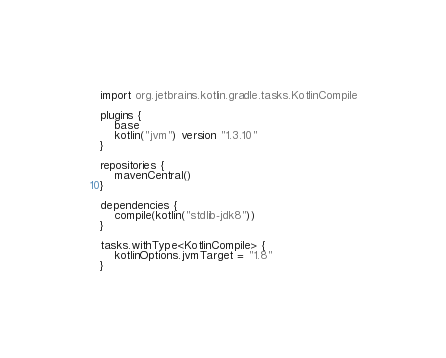<code> <loc_0><loc_0><loc_500><loc_500><_Kotlin_>import org.jetbrains.kotlin.gradle.tasks.KotlinCompile

plugins {
    base
    kotlin("jvm") version "1.3.10"
}

repositories {
    mavenCentral()
}

dependencies {
    compile(kotlin("stdlib-jdk8"))
}

tasks.withType<KotlinCompile> {
    kotlinOptions.jvmTarget = "1.8"
}</code> 